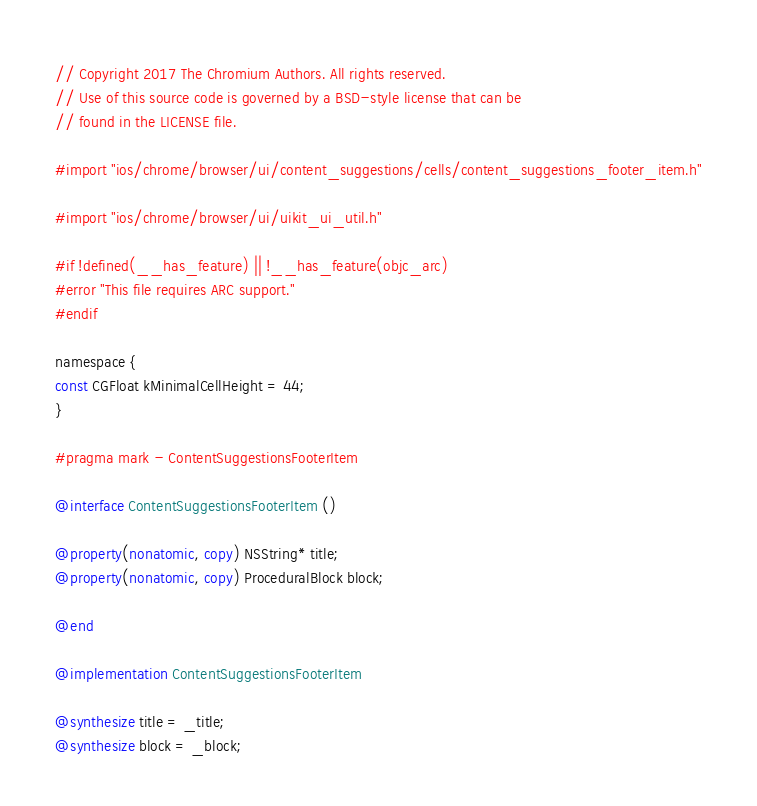<code> <loc_0><loc_0><loc_500><loc_500><_ObjectiveC_>// Copyright 2017 The Chromium Authors. All rights reserved.
// Use of this source code is governed by a BSD-style license that can be
// found in the LICENSE file.

#import "ios/chrome/browser/ui/content_suggestions/cells/content_suggestions_footer_item.h"

#import "ios/chrome/browser/ui/uikit_ui_util.h"

#if !defined(__has_feature) || !__has_feature(objc_arc)
#error "This file requires ARC support."
#endif

namespace {
const CGFloat kMinimalCellHeight = 44;
}

#pragma mark - ContentSuggestionsFooterItem

@interface ContentSuggestionsFooterItem ()

@property(nonatomic, copy) NSString* title;
@property(nonatomic, copy) ProceduralBlock block;

@end

@implementation ContentSuggestionsFooterItem

@synthesize title = _title;
@synthesize block = _block;
</code> 